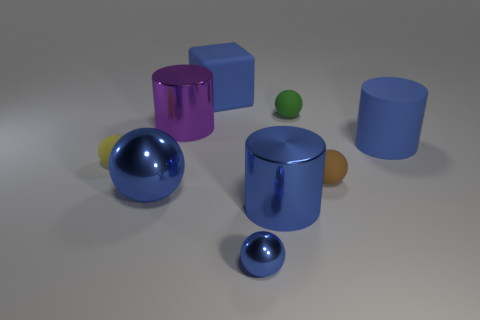Is the material of the tiny brown object the same as the purple thing?
Provide a succinct answer. No. Are there more small matte spheres that are in front of the small green ball than small brown cubes?
Keep it short and to the point. Yes. How many objects are either green things or cylinders in front of the purple metal thing?
Give a very brief answer. 3. Are there more cylinders in front of the small brown rubber thing than tiny blue metallic spheres behind the tiny blue metallic object?
Provide a short and direct response. Yes. What material is the tiny green thing that is on the left side of the tiny matte object that is in front of the small ball to the left of the purple cylinder made of?
Your response must be concise. Rubber. What shape is the big thing that is made of the same material as the block?
Give a very brief answer. Cylinder. Are there any tiny rubber spheres behind the large metal cylinder on the right side of the small metal ball?
Offer a terse response. Yes. How big is the yellow thing?
Provide a short and direct response. Small. How many things are tiny green metallic things or tiny matte things?
Provide a short and direct response. 3. Do the cylinder to the left of the large cube and the blue cylinder in front of the yellow rubber object have the same material?
Make the answer very short. Yes. 